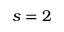<formula> <loc_0><loc_0><loc_500><loc_500>s = 2</formula> 